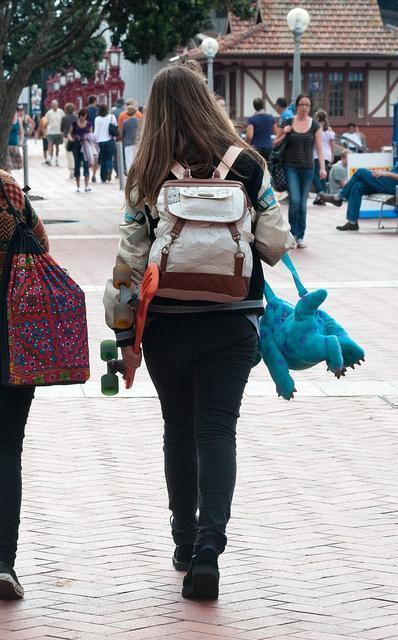What is the dominate color of the object the woman is carrying with her left arm?
Pick the correct solution from the four options below to address the question.
Options: Pink, red, orange, purple. Orange. 